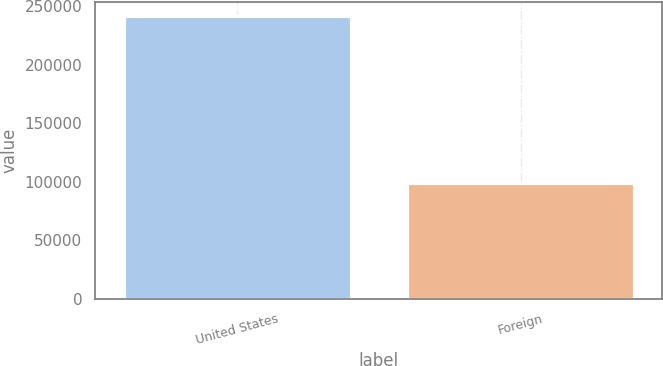Convert chart. <chart><loc_0><loc_0><loc_500><loc_500><bar_chart><fcel>United States<fcel>Foreign<nl><fcel>241470<fcel>98923<nl></chart> 